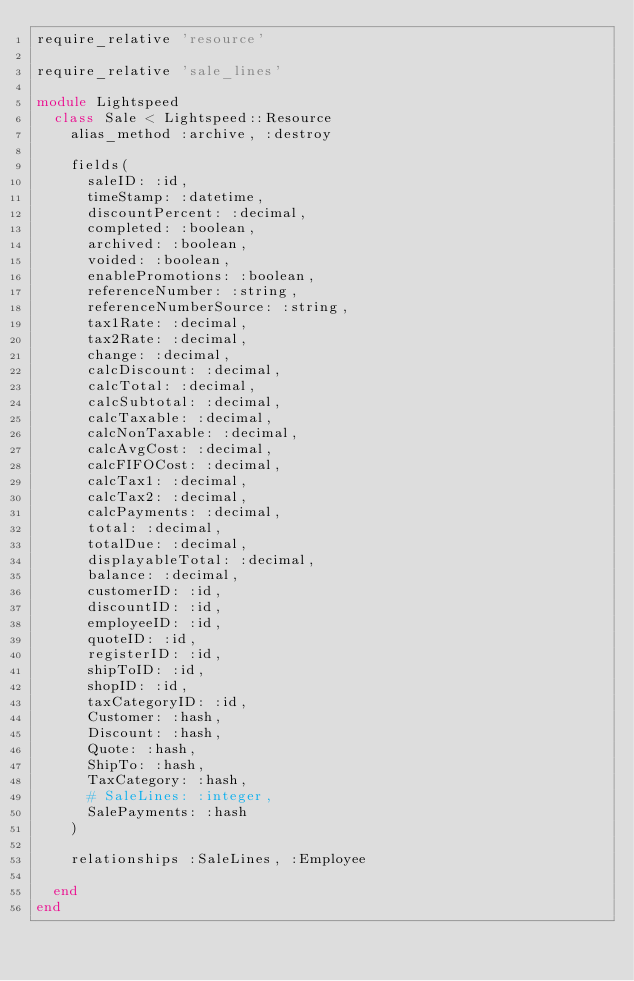<code> <loc_0><loc_0><loc_500><loc_500><_Ruby_>require_relative 'resource'

require_relative 'sale_lines'

module Lightspeed
  class Sale < Lightspeed::Resource
    alias_method :archive, :destroy

    fields(
      saleID: :id,
      timeStamp: :datetime,
      discountPercent: :decimal,
      completed: :boolean,
      archived: :boolean,
      voided: :boolean,
      enablePromotions: :boolean,
      referenceNumber: :string,
      referenceNumberSource: :string,
      tax1Rate: :decimal,
      tax2Rate: :decimal,
      change: :decimal,
      calcDiscount: :decimal,
      calcTotal: :decimal,
      calcSubtotal: :decimal,
      calcTaxable: :decimal,
      calcNonTaxable: :decimal,
      calcAvgCost: :decimal,
      calcFIFOCost: :decimal,
      calcTax1: :decimal,
      calcTax2: :decimal,
      calcPayments: :decimal,
      total: :decimal,
      totalDue: :decimal,
      displayableTotal: :decimal,
      balance: :decimal,
      customerID: :id,
      discountID: :id,
      employeeID: :id,
      quoteID: :id,
      registerID: :id,
      shipToID: :id,
      shopID: :id,
      taxCategoryID: :id,
      Customer: :hash,
      Discount: :hash,
      Quote: :hash,
      ShipTo: :hash,
      TaxCategory: :hash,
      # SaleLines: :integer,
      SalePayments: :hash
    )

    relationships :SaleLines, :Employee

  end
end

</code> 